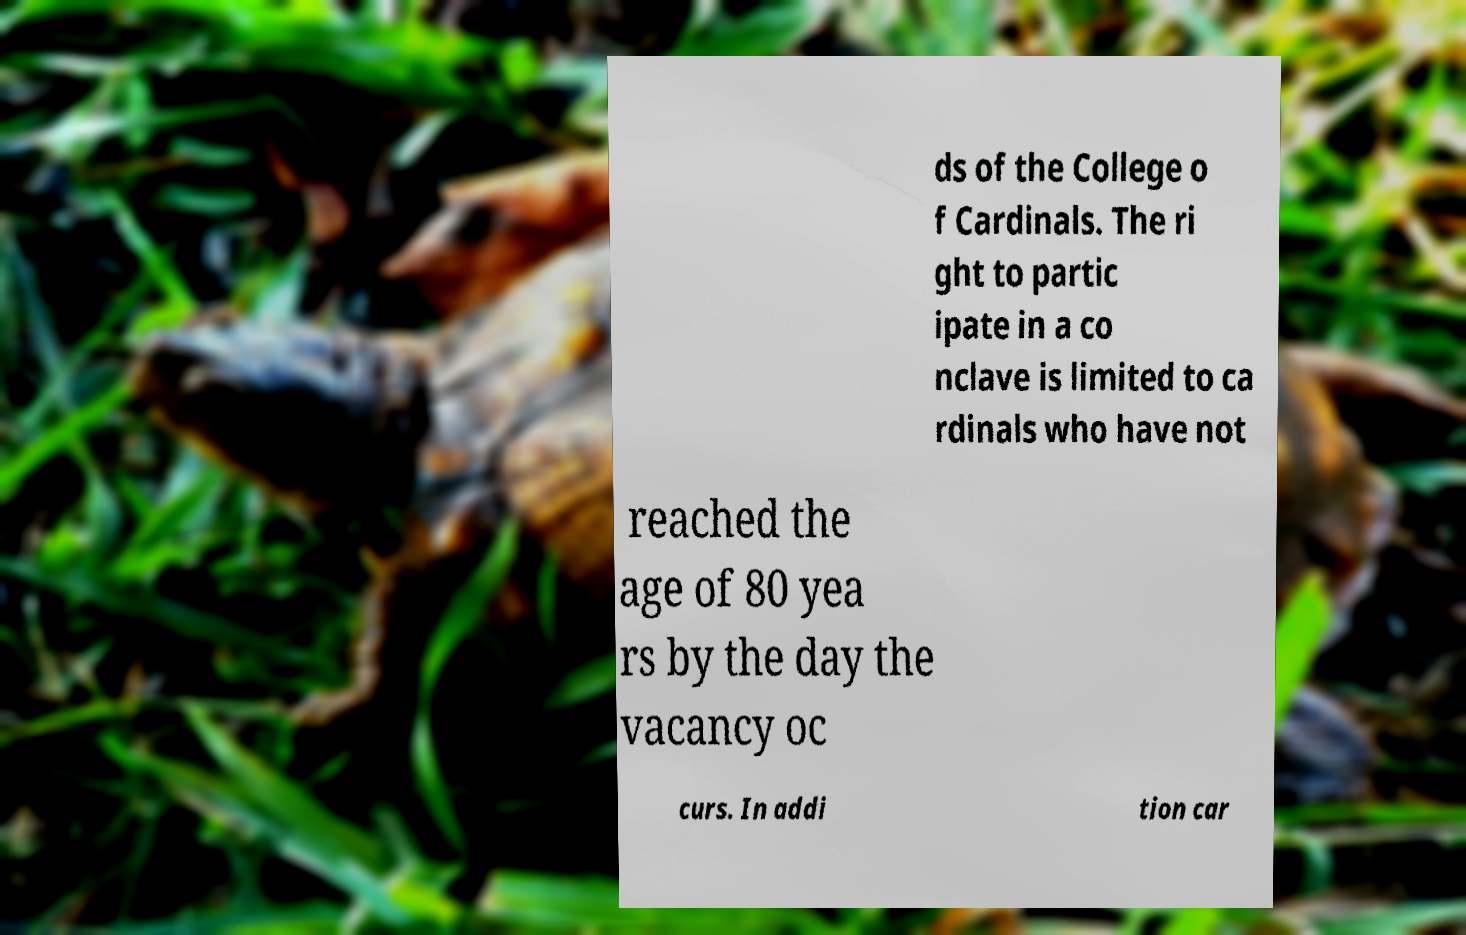For documentation purposes, I need the text within this image transcribed. Could you provide that? ds of the College o f Cardinals. The ri ght to partic ipate in a co nclave is limited to ca rdinals who have not reached the age of 80 yea rs by the day the vacancy oc curs. In addi tion car 